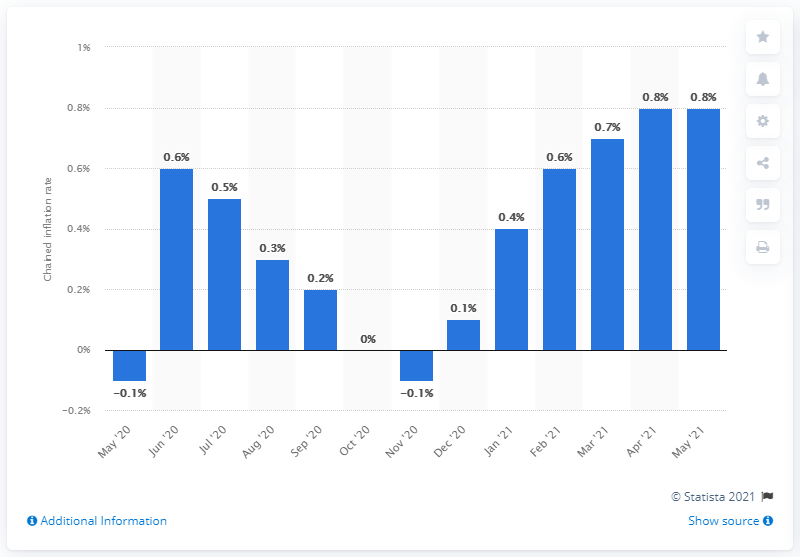Outline some significant characteristics in this image. The chained consumer price index for all urban consumers increased by 0.8% in May 2021, according to the data. 